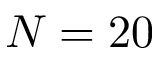<formula> <loc_0><loc_0><loc_500><loc_500>N = 2 0</formula> 